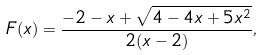<formula> <loc_0><loc_0><loc_500><loc_500>F ( x ) = \frac { - 2 - x + \sqrt { 4 - 4 x + 5 x ^ { 2 } } } { 2 ( x - 2 ) } ,</formula> 